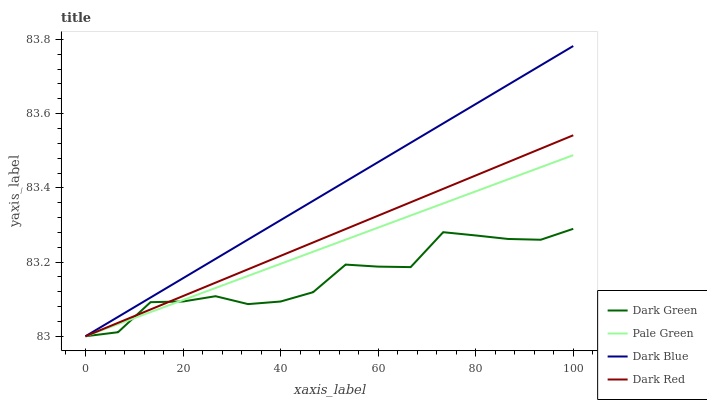Does Dark Green have the minimum area under the curve?
Answer yes or no. Yes. Does Dark Blue have the maximum area under the curve?
Answer yes or no. Yes. Does Pale Green have the minimum area under the curve?
Answer yes or no. No. Does Pale Green have the maximum area under the curve?
Answer yes or no. No. Is Pale Green the smoothest?
Answer yes or no. Yes. Is Dark Green the roughest?
Answer yes or no. Yes. Is Dark Red the smoothest?
Answer yes or no. No. Is Dark Red the roughest?
Answer yes or no. No. Does Pale Green have the highest value?
Answer yes or no. No. 